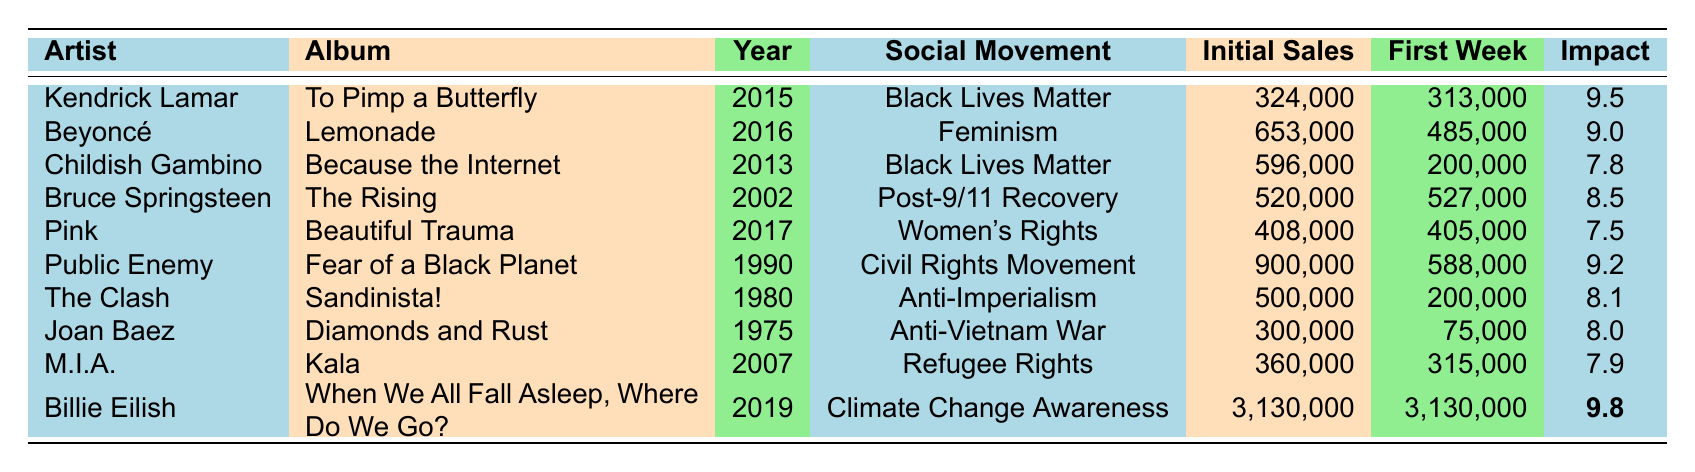What was the initial sales of Billie Eilish's album? The table shows that the initial sales of Billie Eilish's album, "When We All Fall Asleep, Where Do We Go?", is listed as 3,130,000.
Answer: 3,130,000 Which album had the highest impact score? The impact scores are: Kendrick Lamar (9.5), Beyoncé (9.0), Childish Gambino (7.8), Bruce Springsteen (8.5), Pink (7.5), Public Enemy (9.2), The Clash (8.1), Joan Baez (8.0), M.I.A. (7.9), and Billie Eilish (9.8). The highest score is 9.8 from Billie Eilish.
Answer: Billie Eilish's album What was the first week sales of Bruce Springsteen's "The Rising"? The table indicates that the first week sales of Bruce Springsteen's album "The Rising" is 527,000.
Answer: 527,000 What is the difference in initial sales between Kendrick Lamar and Public Enemy? Kendrick Lamar's initial sales is 324,000 and Public Enemy's is 900,000. The difference is 900,000 - 324,000 = 576,000.
Answer: 576,000 Is the impact score of M.I.A.'s album greater than 8? M.I.A.'s impact score is 7.9, which is less than 8. Therefore, the answer is no.
Answer: No Which artist's album related to women's rights had the second lowest initial sales? The two albums related to women's rights are Beyoncé's "Lemonade" with 653,000 and Pink's "Beautiful Trauma" with 408,000. Therefore, Pink's album has the second lowest initial sales among them.
Answer: Pink What is the average initial sales of albums associated with the Black Lives Matter movement? The albums are Kendrick Lamar (324,000) and Childish Gambino (596,000), so the average is (324,000 + 596,000)/2 = 460,000.
Answer: 460,000 How many albums had an impact score of 9 or more? The albums with an impact score of 9 or more are Kendrick Lamar (9.5), Beyoncé (9.0), Public Enemy (9.2), and Billie Eilish (9.8). This totals to 4 albums.
Answer: 4 What was the first week sales for which politically charged album showed a decrease from its first week to initial sales? The only album that showed a decrease from first week sales to initial sales is Childish Gambino's "Because the Internet," with 200,000 first week sales and 596,000 initial sales.
Answer: Childish Gambino's album 